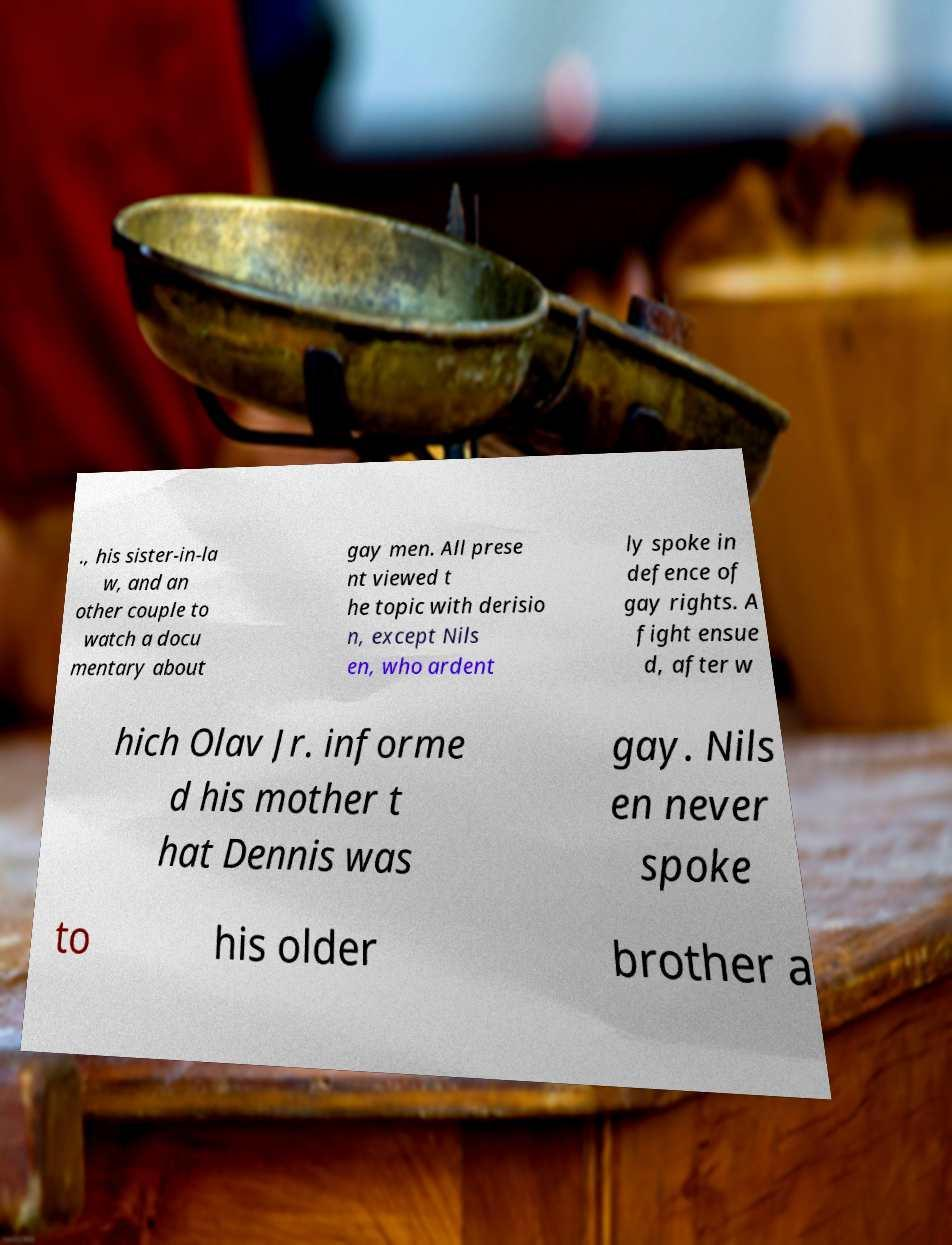Could you assist in decoding the text presented in this image and type it out clearly? ., his sister-in-la w, and an other couple to watch a docu mentary about gay men. All prese nt viewed t he topic with derisio n, except Nils en, who ardent ly spoke in defence of gay rights. A fight ensue d, after w hich Olav Jr. informe d his mother t hat Dennis was gay. Nils en never spoke to his older brother a 